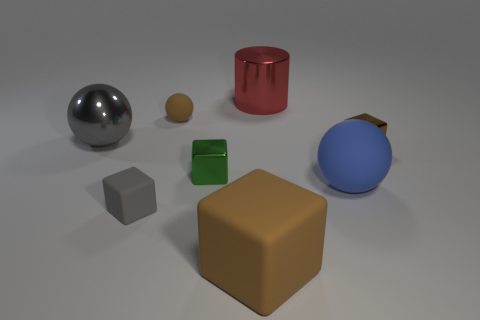Are there any large gray spheres that have the same material as the large cylinder?
Keep it short and to the point. Yes. How many objects are either big things that are to the left of the brown matte block or tiny shiny objects to the left of the cylinder?
Offer a very short reply. 2. Is the shape of the large red thing the same as the matte thing behind the large gray shiny ball?
Offer a terse response. No. How many other things are the same shape as the large blue thing?
Keep it short and to the point. 2. What number of objects are red matte cylinders or big objects?
Keep it short and to the point. 4. Do the tiny matte ball and the shiny cylinder have the same color?
Your answer should be compact. No. Is there anything else that is the same size as the gray rubber cube?
Ensure brevity in your answer.  Yes. What is the shape of the tiny brown thing that is in front of the big metal object left of the red thing?
Your answer should be very brief. Cube. Are there fewer purple cylinders than big cylinders?
Keep it short and to the point. Yes. What is the size of the rubber object that is on the right side of the brown ball and in front of the blue object?
Provide a succinct answer. Large. 